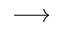<formula> <loc_0><loc_0><loc_500><loc_500>\longrightarrow</formula> 